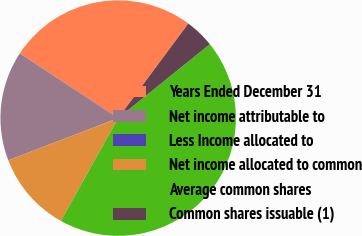Convert chart. <chart><loc_0><loc_0><loc_500><loc_500><pie_chart><fcel>Years Ended December 31<fcel>Net income attributable to<fcel>Less Income allocated to<fcel>Net income allocated to common<fcel>Average common shares<fcel>Common shares issuable (1)<nl><fcel>25.89%<fcel>15.08%<fcel>0.03%<fcel>11.07%<fcel>43.89%<fcel>4.04%<nl></chart> 